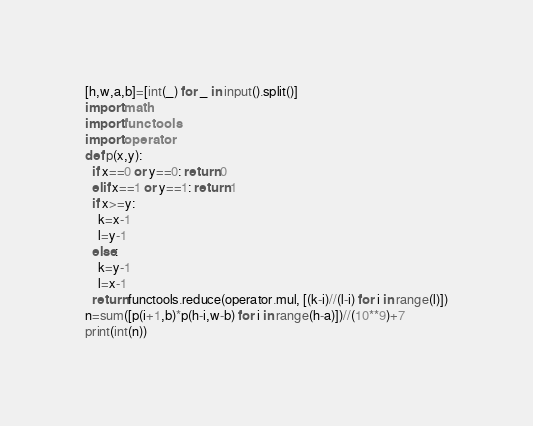<code> <loc_0><loc_0><loc_500><loc_500><_Python_>[h,w,a,b]=[int(_) for _ in input().split()]
import math
import functools
import operator
def p(x,y):
  if x==0 or y==0: return 0
  elif x==1 or y==1: return 1
  if x>=y: 
    k=x-1
    l=y-1
  else:
    k=y-1
    l=x-1
  return functools.reduce(operator.mul, [(k-i)//(l-i) for i in range(l)])
n=sum([p(i+1,b)*p(h-i,w-b) for i in range(h-a)])//(10**9)+7
print(int(n))</code> 